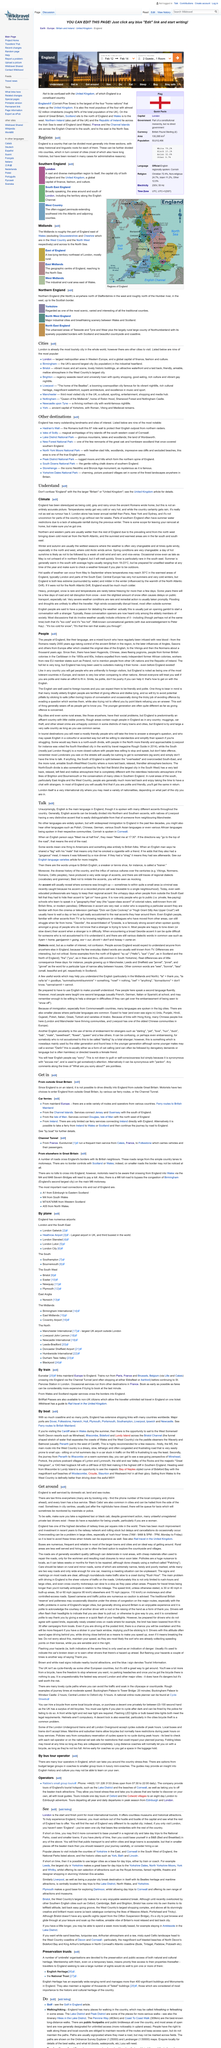Outline some significant characteristics in this image. Overcrowding in large cities on the railway network is a significant problem that can negatively impact commuters, travelers, and the overall transportation system. In England, walking in the countryside is also known as hillwalking or fellwalking, in addition to its primary name. Yes, regular train services from Wales and Scotland cross the border into England. England is a place that is well-served by domestic air, land, and sea routes. Rail travel in the United Kingdom can be navigated through a guide available on Wikitravel. 